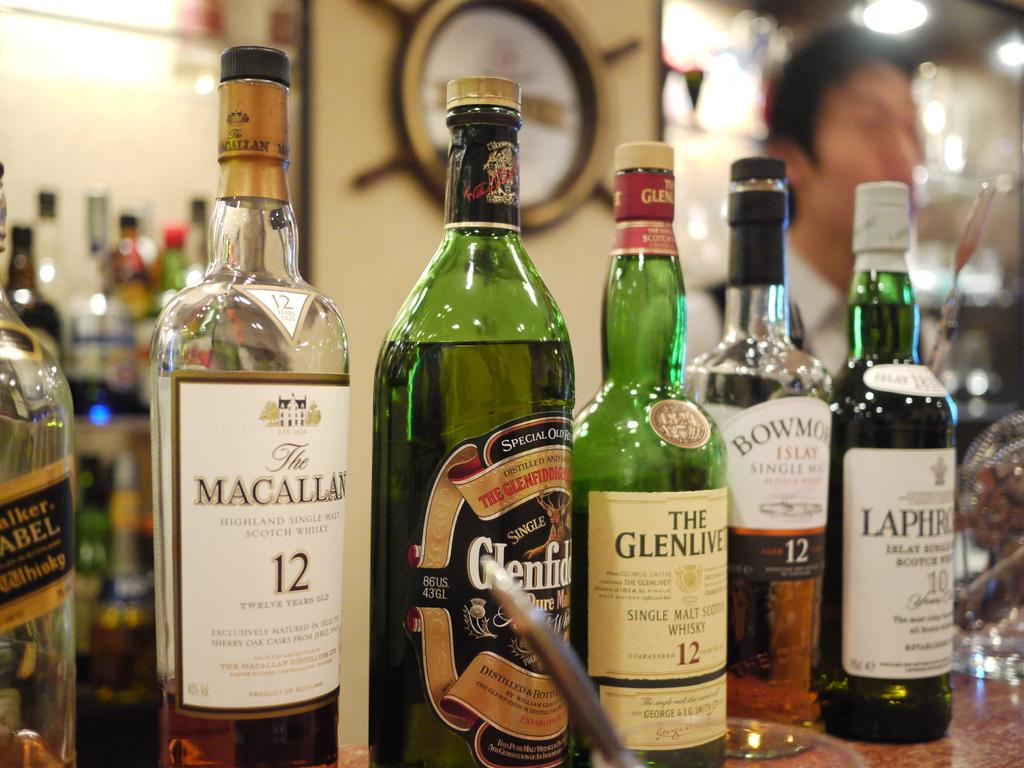Provide a one-sentence caption for the provided image. A green bottle thats say glenlivit on the label. 